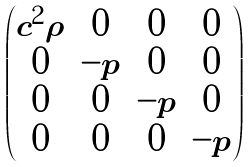Convert formula to latex. <formula><loc_0><loc_0><loc_500><loc_500>\begin{pmatrix} c ^ { 2 } \rho & 0 & 0 & 0 \\ 0 & - p & 0 & 0 \\ 0 & 0 & - p & 0 \\ 0 & 0 & 0 & - p \end{pmatrix}</formula> 